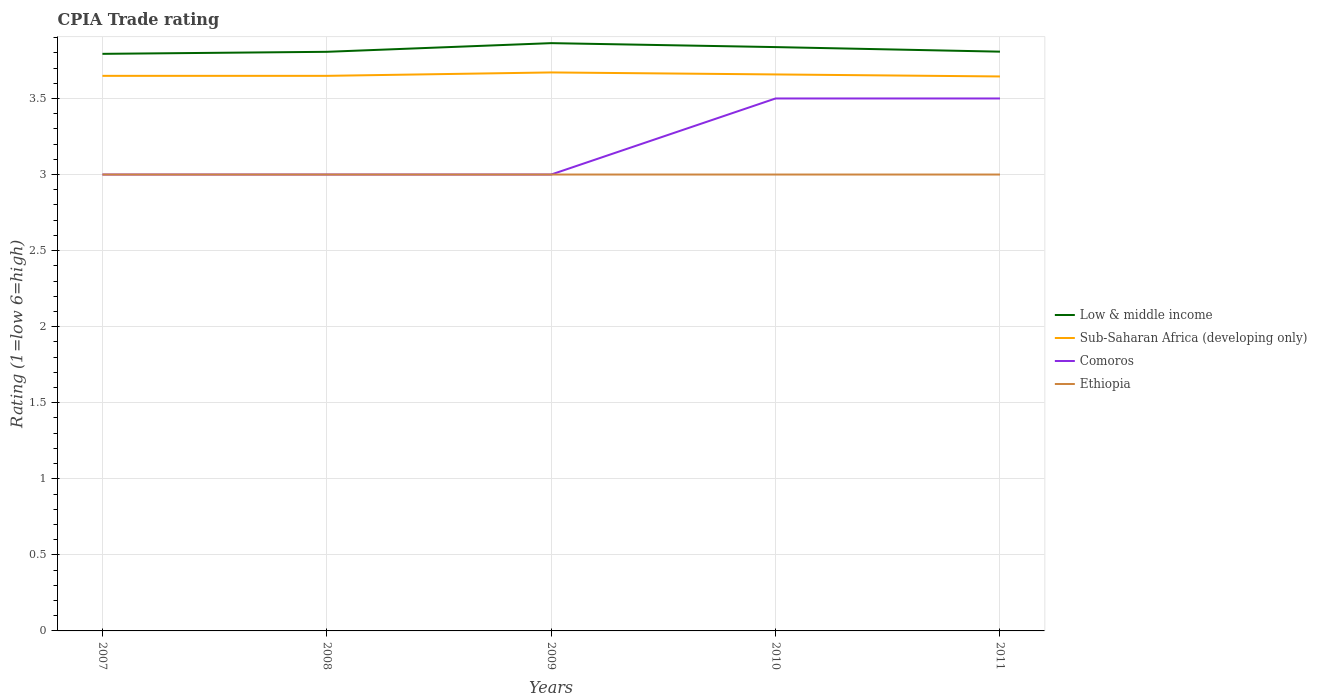Does the line corresponding to Ethiopia intersect with the line corresponding to Sub-Saharan Africa (developing only)?
Offer a terse response. No. Across all years, what is the maximum CPIA rating in Low & middle income?
Your answer should be compact. 3.79. Is the CPIA rating in Ethiopia strictly greater than the CPIA rating in Sub-Saharan Africa (developing only) over the years?
Ensure brevity in your answer.  Yes. How many lines are there?
Keep it short and to the point. 4. What is the difference between two consecutive major ticks on the Y-axis?
Make the answer very short. 0.5. Does the graph contain any zero values?
Provide a succinct answer. No. What is the title of the graph?
Make the answer very short. CPIA Trade rating. Does "Japan" appear as one of the legend labels in the graph?
Make the answer very short. No. What is the label or title of the X-axis?
Ensure brevity in your answer.  Years. What is the Rating (1=low 6=high) of Low & middle income in 2007?
Give a very brief answer. 3.79. What is the Rating (1=low 6=high) of Sub-Saharan Africa (developing only) in 2007?
Offer a terse response. 3.65. What is the Rating (1=low 6=high) in Comoros in 2007?
Offer a very short reply. 3. What is the Rating (1=low 6=high) in Ethiopia in 2007?
Give a very brief answer. 3. What is the Rating (1=low 6=high) in Low & middle income in 2008?
Give a very brief answer. 3.81. What is the Rating (1=low 6=high) of Sub-Saharan Africa (developing only) in 2008?
Provide a short and direct response. 3.65. What is the Rating (1=low 6=high) in Comoros in 2008?
Offer a very short reply. 3. What is the Rating (1=low 6=high) of Low & middle income in 2009?
Your answer should be very brief. 3.86. What is the Rating (1=low 6=high) of Sub-Saharan Africa (developing only) in 2009?
Ensure brevity in your answer.  3.67. What is the Rating (1=low 6=high) in Ethiopia in 2009?
Keep it short and to the point. 3. What is the Rating (1=low 6=high) in Low & middle income in 2010?
Make the answer very short. 3.84. What is the Rating (1=low 6=high) in Sub-Saharan Africa (developing only) in 2010?
Give a very brief answer. 3.66. What is the Rating (1=low 6=high) of Low & middle income in 2011?
Your answer should be compact. 3.81. What is the Rating (1=low 6=high) in Sub-Saharan Africa (developing only) in 2011?
Provide a succinct answer. 3.64. What is the Rating (1=low 6=high) of Ethiopia in 2011?
Your response must be concise. 3. Across all years, what is the maximum Rating (1=low 6=high) of Low & middle income?
Offer a terse response. 3.86. Across all years, what is the maximum Rating (1=low 6=high) in Sub-Saharan Africa (developing only)?
Give a very brief answer. 3.67. Across all years, what is the maximum Rating (1=low 6=high) of Comoros?
Provide a succinct answer. 3.5. Across all years, what is the minimum Rating (1=low 6=high) of Low & middle income?
Give a very brief answer. 3.79. Across all years, what is the minimum Rating (1=low 6=high) in Sub-Saharan Africa (developing only)?
Your answer should be compact. 3.64. Across all years, what is the minimum Rating (1=low 6=high) in Comoros?
Keep it short and to the point. 3. What is the total Rating (1=low 6=high) in Low & middle income in the graph?
Make the answer very short. 19.11. What is the total Rating (1=low 6=high) in Sub-Saharan Africa (developing only) in the graph?
Your answer should be very brief. 18.27. What is the difference between the Rating (1=low 6=high) in Low & middle income in 2007 and that in 2008?
Give a very brief answer. -0.01. What is the difference between the Rating (1=low 6=high) in Comoros in 2007 and that in 2008?
Give a very brief answer. 0. What is the difference between the Rating (1=low 6=high) of Ethiopia in 2007 and that in 2008?
Provide a succinct answer. 0. What is the difference between the Rating (1=low 6=high) in Low & middle income in 2007 and that in 2009?
Give a very brief answer. -0.07. What is the difference between the Rating (1=low 6=high) of Sub-Saharan Africa (developing only) in 2007 and that in 2009?
Offer a terse response. -0.02. What is the difference between the Rating (1=low 6=high) of Comoros in 2007 and that in 2009?
Offer a terse response. 0. What is the difference between the Rating (1=low 6=high) of Low & middle income in 2007 and that in 2010?
Offer a very short reply. -0.04. What is the difference between the Rating (1=low 6=high) in Sub-Saharan Africa (developing only) in 2007 and that in 2010?
Give a very brief answer. -0.01. What is the difference between the Rating (1=low 6=high) in Comoros in 2007 and that in 2010?
Offer a terse response. -0.5. What is the difference between the Rating (1=low 6=high) in Low & middle income in 2007 and that in 2011?
Provide a succinct answer. -0.01. What is the difference between the Rating (1=low 6=high) in Sub-Saharan Africa (developing only) in 2007 and that in 2011?
Your response must be concise. 0. What is the difference between the Rating (1=low 6=high) in Comoros in 2007 and that in 2011?
Provide a succinct answer. -0.5. What is the difference between the Rating (1=low 6=high) of Low & middle income in 2008 and that in 2009?
Make the answer very short. -0.06. What is the difference between the Rating (1=low 6=high) of Sub-Saharan Africa (developing only) in 2008 and that in 2009?
Your response must be concise. -0.02. What is the difference between the Rating (1=low 6=high) of Comoros in 2008 and that in 2009?
Provide a short and direct response. 0. What is the difference between the Rating (1=low 6=high) in Low & middle income in 2008 and that in 2010?
Keep it short and to the point. -0.03. What is the difference between the Rating (1=low 6=high) in Sub-Saharan Africa (developing only) in 2008 and that in 2010?
Keep it short and to the point. -0.01. What is the difference between the Rating (1=low 6=high) of Low & middle income in 2008 and that in 2011?
Provide a short and direct response. -0. What is the difference between the Rating (1=low 6=high) in Sub-Saharan Africa (developing only) in 2008 and that in 2011?
Keep it short and to the point. 0. What is the difference between the Rating (1=low 6=high) in Ethiopia in 2008 and that in 2011?
Your answer should be compact. 0. What is the difference between the Rating (1=low 6=high) of Low & middle income in 2009 and that in 2010?
Provide a short and direct response. 0.03. What is the difference between the Rating (1=low 6=high) in Sub-Saharan Africa (developing only) in 2009 and that in 2010?
Provide a short and direct response. 0.01. What is the difference between the Rating (1=low 6=high) in Comoros in 2009 and that in 2010?
Your answer should be compact. -0.5. What is the difference between the Rating (1=low 6=high) in Ethiopia in 2009 and that in 2010?
Ensure brevity in your answer.  0. What is the difference between the Rating (1=low 6=high) of Low & middle income in 2009 and that in 2011?
Your answer should be very brief. 0.06. What is the difference between the Rating (1=low 6=high) in Sub-Saharan Africa (developing only) in 2009 and that in 2011?
Your answer should be compact. 0.03. What is the difference between the Rating (1=low 6=high) in Comoros in 2009 and that in 2011?
Offer a terse response. -0.5. What is the difference between the Rating (1=low 6=high) of Ethiopia in 2009 and that in 2011?
Ensure brevity in your answer.  0. What is the difference between the Rating (1=low 6=high) in Low & middle income in 2010 and that in 2011?
Make the answer very short. 0.03. What is the difference between the Rating (1=low 6=high) of Sub-Saharan Africa (developing only) in 2010 and that in 2011?
Your response must be concise. 0.01. What is the difference between the Rating (1=low 6=high) in Low & middle income in 2007 and the Rating (1=low 6=high) in Sub-Saharan Africa (developing only) in 2008?
Offer a terse response. 0.14. What is the difference between the Rating (1=low 6=high) in Low & middle income in 2007 and the Rating (1=low 6=high) in Comoros in 2008?
Your answer should be very brief. 0.79. What is the difference between the Rating (1=low 6=high) of Low & middle income in 2007 and the Rating (1=low 6=high) of Ethiopia in 2008?
Offer a terse response. 0.79. What is the difference between the Rating (1=low 6=high) in Sub-Saharan Africa (developing only) in 2007 and the Rating (1=low 6=high) in Comoros in 2008?
Keep it short and to the point. 0.65. What is the difference between the Rating (1=low 6=high) in Sub-Saharan Africa (developing only) in 2007 and the Rating (1=low 6=high) in Ethiopia in 2008?
Ensure brevity in your answer.  0.65. What is the difference between the Rating (1=low 6=high) of Comoros in 2007 and the Rating (1=low 6=high) of Ethiopia in 2008?
Offer a very short reply. 0. What is the difference between the Rating (1=low 6=high) of Low & middle income in 2007 and the Rating (1=low 6=high) of Sub-Saharan Africa (developing only) in 2009?
Offer a very short reply. 0.12. What is the difference between the Rating (1=low 6=high) in Low & middle income in 2007 and the Rating (1=low 6=high) in Comoros in 2009?
Ensure brevity in your answer.  0.79. What is the difference between the Rating (1=low 6=high) of Low & middle income in 2007 and the Rating (1=low 6=high) of Ethiopia in 2009?
Give a very brief answer. 0.79. What is the difference between the Rating (1=low 6=high) in Sub-Saharan Africa (developing only) in 2007 and the Rating (1=low 6=high) in Comoros in 2009?
Provide a succinct answer. 0.65. What is the difference between the Rating (1=low 6=high) of Sub-Saharan Africa (developing only) in 2007 and the Rating (1=low 6=high) of Ethiopia in 2009?
Ensure brevity in your answer.  0.65. What is the difference between the Rating (1=low 6=high) of Low & middle income in 2007 and the Rating (1=low 6=high) of Sub-Saharan Africa (developing only) in 2010?
Offer a very short reply. 0.14. What is the difference between the Rating (1=low 6=high) in Low & middle income in 2007 and the Rating (1=low 6=high) in Comoros in 2010?
Your response must be concise. 0.29. What is the difference between the Rating (1=low 6=high) of Low & middle income in 2007 and the Rating (1=low 6=high) of Ethiopia in 2010?
Your answer should be very brief. 0.79. What is the difference between the Rating (1=low 6=high) of Sub-Saharan Africa (developing only) in 2007 and the Rating (1=low 6=high) of Comoros in 2010?
Offer a terse response. 0.15. What is the difference between the Rating (1=low 6=high) in Sub-Saharan Africa (developing only) in 2007 and the Rating (1=low 6=high) in Ethiopia in 2010?
Make the answer very short. 0.65. What is the difference between the Rating (1=low 6=high) in Low & middle income in 2007 and the Rating (1=low 6=high) in Sub-Saharan Africa (developing only) in 2011?
Offer a very short reply. 0.15. What is the difference between the Rating (1=low 6=high) in Low & middle income in 2007 and the Rating (1=low 6=high) in Comoros in 2011?
Your answer should be very brief. 0.29. What is the difference between the Rating (1=low 6=high) of Low & middle income in 2007 and the Rating (1=low 6=high) of Ethiopia in 2011?
Offer a very short reply. 0.79. What is the difference between the Rating (1=low 6=high) of Sub-Saharan Africa (developing only) in 2007 and the Rating (1=low 6=high) of Comoros in 2011?
Offer a terse response. 0.15. What is the difference between the Rating (1=low 6=high) in Sub-Saharan Africa (developing only) in 2007 and the Rating (1=low 6=high) in Ethiopia in 2011?
Provide a succinct answer. 0.65. What is the difference between the Rating (1=low 6=high) of Low & middle income in 2008 and the Rating (1=low 6=high) of Sub-Saharan Africa (developing only) in 2009?
Offer a terse response. 0.14. What is the difference between the Rating (1=low 6=high) of Low & middle income in 2008 and the Rating (1=low 6=high) of Comoros in 2009?
Your answer should be very brief. 0.81. What is the difference between the Rating (1=low 6=high) in Low & middle income in 2008 and the Rating (1=low 6=high) in Ethiopia in 2009?
Your answer should be very brief. 0.81. What is the difference between the Rating (1=low 6=high) of Sub-Saharan Africa (developing only) in 2008 and the Rating (1=low 6=high) of Comoros in 2009?
Make the answer very short. 0.65. What is the difference between the Rating (1=low 6=high) of Sub-Saharan Africa (developing only) in 2008 and the Rating (1=low 6=high) of Ethiopia in 2009?
Offer a terse response. 0.65. What is the difference between the Rating (1=low 6=high) of Low & middle income in 2008 and the Rating (1=low 6=high) of Sub-Saharan Africa (developing only) in 2010?
Give a very brief answer. 0.15. What is the difference between the Rating (1=low 6=high) in Low & middle income in 2008 and the Rating (1=low 6=high) in Comoros in 2010?
Offer a terse response. 0.31. What is the difference between the Rating (1=low 6=high) in Low & middle income in 2008 and the Rating (1=low 6=high) in Ethiopia in 2010?
Ensure brevity in your answer.  0.81. What is the difference between the Rating (1=low 6=high) of Sub-Saharan Africa (developing only) in 2008 and the Rating (1=low 6=high) of Comoros in 2010?
Keep it short and to the point. 0.15. What is the difference between the Rating (1=low 6=high) of Sub-Saharan Africa (developing only) in 2008 and the Rating (1=low 6=high) of Ethiopia in 2010?
Give a very brief answer. 0.65. What is the difference between the Rating (1=low 6=high) in Low & middle income in 2008 and the Rating (1=low 6=high) in Sub-Saharan Africa (developing only) in 2011?
Ensure brevity in your answer.  0.16. What is the difference between the Rating (1=low 6=high) of Low & middle income in 2008 and the Rating (1=low 6=high) of Comoros in 2011?
Offer a terse response. 0.31. What is the difference between the Rating (1=low 6=high) in Low & middle income in 2008 and the Rating (1=low 6=high) in Ethiopia in 2011?
Offer a terse response. 0.81. What is the difference between the Rating (1=low 6=high) of Sub-Saharan Africa (developing only) in 2008 and the Rating (1=low 6=high) of Comoros in 2011?
Keep it short and to the point. 0.15. What is the difference between the Rating (1=low 6=high) of Sub-Saharan Africa (developing only) in 2008 and the Rating (1=low 6=high) of Ethiopia in 2011?
Offer a terse response. 0.65. What is the difference between the Rating (1=low 6=high) in Low & middle income in 2009 and the Rating (1=low 6=high) in Sub-Saharan Africa (developing only) in 2010?
Offer a terse response. 0.21. What is the difference between the Rating (1=low 6=high) in Low & middle income in 2009 and the Rating (1=low 6=high) in Comoros in 2010?
Your answer should be very brief. 0.36. What is the difference between the Rating (1=low 6=high) of Low & middle income in 2009 and the Rating (1=low 6=high) of Ethiopia in 2010?
Make the answer very short. 0.86. What is the difference between the Rating (1=low 6=high) of Sub-Saharan Africa (developing only) in 2009 and the Rating (1=low 6=high) of Comoros in 2010?
Your response must be concise. 0.17. What is the difference between the Rating (1=low 6=high) of Sub-Saharan Africa (developing only) in 2009 and the Rating (1=low 6=high) of Ethiopia in 2010?
Your response must be concise. 0.67. What is the difference between the Rating (1=low 6=high) of Low & middle income in 2009 and the Rating (1=low 6=high) of Sub-Saharan Africa (developing only) in 2011?
Your response must be concise. 0.22. What is the difference between the Rating (1=low 6=high) in Low & middle income in 2009 and the Rating (1=low 6=high) in Comoros in 2011?
Make the answer very short. 0.36. What is the difference between the Rating (1=low 6=high) of Low & middle income in 2009 and the Rating (1=low 6=high) of Ethiopia in 2011?
Provide a succinct answer. 0.86. What is the difference between the Rating (1=low 6=high) in Sub-Saharan Africa (developing only) in 2009 and the Rating (1=low 6=high) in Comoros in 2011?
Provide a short and direct response. 0.17. What is the difference between the Rating (1=low 6=high) of Sub-Saharan Africa (developing only) in 2009 and the Rating (1=low 6=high) of Ethiopia in 2011?
Ensure brevity in your answer.  0.67. What is the difference between the Rating (1=low 6=high) in Low & middle income in 2010 and the Rating (1=low 6=high) in Sub-Saharan Africa (developing only) in 2011?
Offer a terse response. 0.19. What is the difference between the Rating (1=low 6=high) of Low & middle income in 2010 and the Rating (1=low 6=high) of Comoros in 2011?
Offer a very short reply. 0.34. What is the difference between the Rating (1=low 6=high) in Low & middle income in 2010 and the Rating (1=low 6=high) in Ethiopia in 2011?
Offer a very short reply. 0.84. What is the difference between the Rating (1=low 6=high) of Sub-Saharan Africa (developing only) in 2010 and the Rating (1=low 6=high) of Comoros in 2011?
Keep it short and to the point. 0.16. What is the difference between the Rating (1=low 6=high) in Sub-Saharan Africa (developing only) in 2010 and the Rating (1=low 6=high) in Ethiopia in 2011?
Give a very brief answer. 0.66. What is the difference between the Rating (1=low 6=high) in Comoros in 2010 and the Rating (1=low 6=high) in Ethiopia in 2011?
Provide a succinct answer. 0.5. What is the average Rating (1=low 6=high) of Low & middle income per year?
Ensure brevity in your answer.  3.82. What is the average Rating (1=low 6=high) of Sub-Saharan Africa (developing only) per year?
Make the answer very short. 3.65. What is the average Rating (1=low 6=high) of Comoros per year?
Make the answer very short. 3.2. In the year 2007, what is the difference between the Rating (1=low 6=high) of Low & middle income and Rating (1=low 6=high) of Sub-Saharan Africa (developing only)?
Ensure brevity in your answer.  0.14. In the year 2007, what is the difference between the Rating (1=low 6=high) in Low & middle income and Rating (1=low 6=high) in Comoros?
Offer a very short reply. 0.79. In the year 2007, what is the difference between the Rating (1=low 6=high) in Low & middle income and Rating (1=low 6=high) in Ethiopia?
Make the answer very short. 0.79. In the year 2007, what is the difference between the Rating (1=low 6=high) of Sub-Saharan Africa (developing only) and Rating (1=low 6=high) of Comoros?
Offer a very short reply. 0.65. In the year 2007, what is the difference between the Rating (1=low 6=high) in Sub-Saharan Africa (developing only) and Rating (1=low 6=high) in Ethiopia?
Provide a succinct answer. 0.65. In the year 2008, what is the difference between the Rating (1=low 6=high) in Low & middle income and Rating (1=low 6=high) in Sub-Saharan Africa (developing only)?
Your answer should be very brief. 0.16. In the year 2008, what is the difference between the Rating (1=low 6=high) of Low & middle income and Rating (1=low 6=high) of Comoros?
Your answer should be compact. 0.81. In the year 2008, what is the difference between the Rating (1=low 6=high) in Low & middle income and Rating (1=low 6=high) in Ethiopia?
Make the answer very short. 0.81. In the year 2008, what is the difference between the Rating (1=low 6=high) in Sub-Saharan Africa (developing only) and Rating (1=low 6=high) in Comoros?
Offer a very short reply. 0.65. In the year 2008, what is the difference between the Rating (1=low 6=high) of Sub-Saharan Africa (developing only) and Rating (1=low 6=high) of Ethiopia?
Your answer should be compact. 0.65. In the year 2009, what is the difference between the Rating (1=low 6=high) of Low & middle income and Rating (1=low 6=high) of Sub-Saharan Africa (developing only)?
Your response must be concise. 0.19. In the year 2009, what is the difference between the Rating (1=low 6=high) of Low & middle income and Rating (1=low 6=high) of Comoros?
Make the answer very short. 0.86. In the year 2009, what is the difference between the Rating (1=low 6=high) of Low & middle income and Rating (1=low 6=high) of Ethiopia?
Provide a succinct answer. 0.86. In the year 2009, what is the difference between the Rating (1=low 6=high) of Sub-Saharan Africa (developing only) and Rating (1=low 6=high) of Comoros?
Offer a terse response. 0.67. In the year 2009, what is the difference between the Rating (1=low 6=high) of Sub-Saharan Africa (developing only) and Rating (1=low 6=high) of Ethiopia?
Keep it short and to the point. 0.67. In the year 2009, what is the difference between the Rating (1=low 6=high) of Comoros and Rating (1=low 6=high) of Ethiopia?
Ensure brevity in your answer.  0. In the year 2010, what is the difference between the Rating (1=low 6=high) in Low & middle income and Rating (1=low 6=high) in Sub-Saharan Africa (developing only)?
Offer a very short reply. 0.18. In the year 2010, what is the difference between the Rating (1=low 6=high) of Low & middle income and Rating (1=low 6=high) of Comoros?
Ensure brevity in your answer.  0.34. In the year 2010, what is the difference between the Rating (1=low 6=high) in Low & middle income and Rating (1=low 6=high) in Ethiopia?
Give a very brief answer. 0.84. In the year 2010, what is the difference between the Rating (1=low 6=high) in Sub-Saharan Africa (developing only) and Rating (1=low 6=high) in Comoros?
Give a very brief answer. 0.16. In the year 2010, what is the difference between the Rating (1=low 6=high) of Sub-Saharan Africa (developing only) and Rating (1=low 6=high) of Ethiopia?
Your answer should be compact. 0.66. In the year 2011, what is the difference between the Rating (1=low 6=high) of Low & middle income and Rating (1=low 6=high) of Sub-Saharan Africa (developing only)?
Offer a terse response. 0.16. In the year 2011, what is the difference between the Rating (1=low 6=high) of Low & middle income and Rating (1=low 6=high) of Comoros?
Offer a terse response. 0.31. In the year 2011, what is the difference between the Rating (1=low 6=high) in Low & middle income and Rating (1=low 6=high) in Ethiopia?
Provide a short and direct response. 0.81. In the year 2011, what is the difference between the Rating (1=low 6=high) of Sub-Saharan Africa (developing only) and Rating (1=low 6=high) of Comoros?
Give a very brief answer. 0.14. In the year 2011, what is the difference between the Rating (1=low 6=high) in Sub-Saharan Africa (developing only) and Rating (1=low 6=high) in Ethiopia?
Your response must be concise. 0.64. What is the ratio of the Rating (1=low 6=high) of Low & middle income in 2007 to that in 2008?
Make the answer very short. 1. What is the ratio of the Rating (1=low 6=high) of Sub-Saharan Africa (developing only) in 2007 to that in 2008?
Make the answer very short. 1. What is the ratio of the Rating (1=low 6=high) of Comoros in 2007 to that in 2008?
Your answer should be very brief. 1. What is the ratio of the Rating (1=low 6=high) of Low & middle income in 2007 to that in 2009?
Your answer should be compact. 0.98. What is the ratio of the Rating (1=low 6=high) of Ethiopia in 2007 to that in 2009?
Your answer should be very brief. 1. What is the ratio of the Rating (1=low 6=high) of Low & middle income in 2007 to that in 2010?
Ensure brevity in your answer.  0.99. What is the ratio of the Rating (1=low 6=high) in Sub-Saharan Africa (developing only) in 2007 to that in 2010?
Offer a very short reply. 1. What is the ratio of the Rating (1=low 6=high) in Comoros in 2007 to that in 2010?
Make the answer very short. 0.86. What is the ratio of the Rating (1=low 6=high) of Ethiopia in 2007 to that in 2011?
Your answer should be compact. 1. What is the ratio of the Rating (1=low 6=high) in Low & middle income in 2008 to that in 2009?
Offer a terse response. 0.99. What is the ratio of the Rating (1=low 6=high) in Comoros in 2008 to that in 2009?
Give a very brief answer. 1. What is the ratio of the Rating (1=low 6=high) of Ethiopia in 2008 to that in 2009?
Offer a very short reply. 1. What is the ratio of the Rating (1=low 6=high) in Sub-Saharan Africa (developing only) in 2008 to that in 2010?
Your response must be concise. 1. What is the ratio of the Rating (1=low 6=high) of Comoros in 2008 to that in 2011?
Offer a very short reply. 0.86. What is the ratio of the Rating (1=low 6=high) of Low & middle income in 2009 to that in 2010?
Your answer should be compact. 1.01. What is the ratio of the Rating (1=low 6=high) in Comoros in 2009 to that in 2010?
Offer a very short reply. 0.86. What is the ratio of the Rating (1=low 6=high) in Low & middle income in 2009 to that in 2011?
Offer a very short reply. 1.01. What is the ratio of the Rating (1=low 6=high) of Comoros in 2009 to that in 2011?
Provide a succinct answer. 0.86. What is the ratio of the Rating (1=low 6=high) of Low & middle income in 2010 to that in 2011?
Keep it short and to the point. 1.01. What is the difference between the highest and the second highest Rating (1=low 6=high) of Low & middle income?
Your answer should be compact. 0.03. What is the difference between the highest and the second highest Rating (1=low 6=high) of Sub-Saharan Africa (developing only)?
Offer a very short reply. 0.01. What is the difference between the highest and the lowest Rating (1=low 6=high) in Low & middle income?
Give a very brief answer. 0.07. What is the difference between the highest and the lowest Rating (1=low 6=high) of Sub-Saharan Africa (developing only)?
Offer a very short reply. 0.03. What is the difference between the highest and the lowest Rating (1=low 6=high) of Ethiopia?
Make the answer very short. 0. 